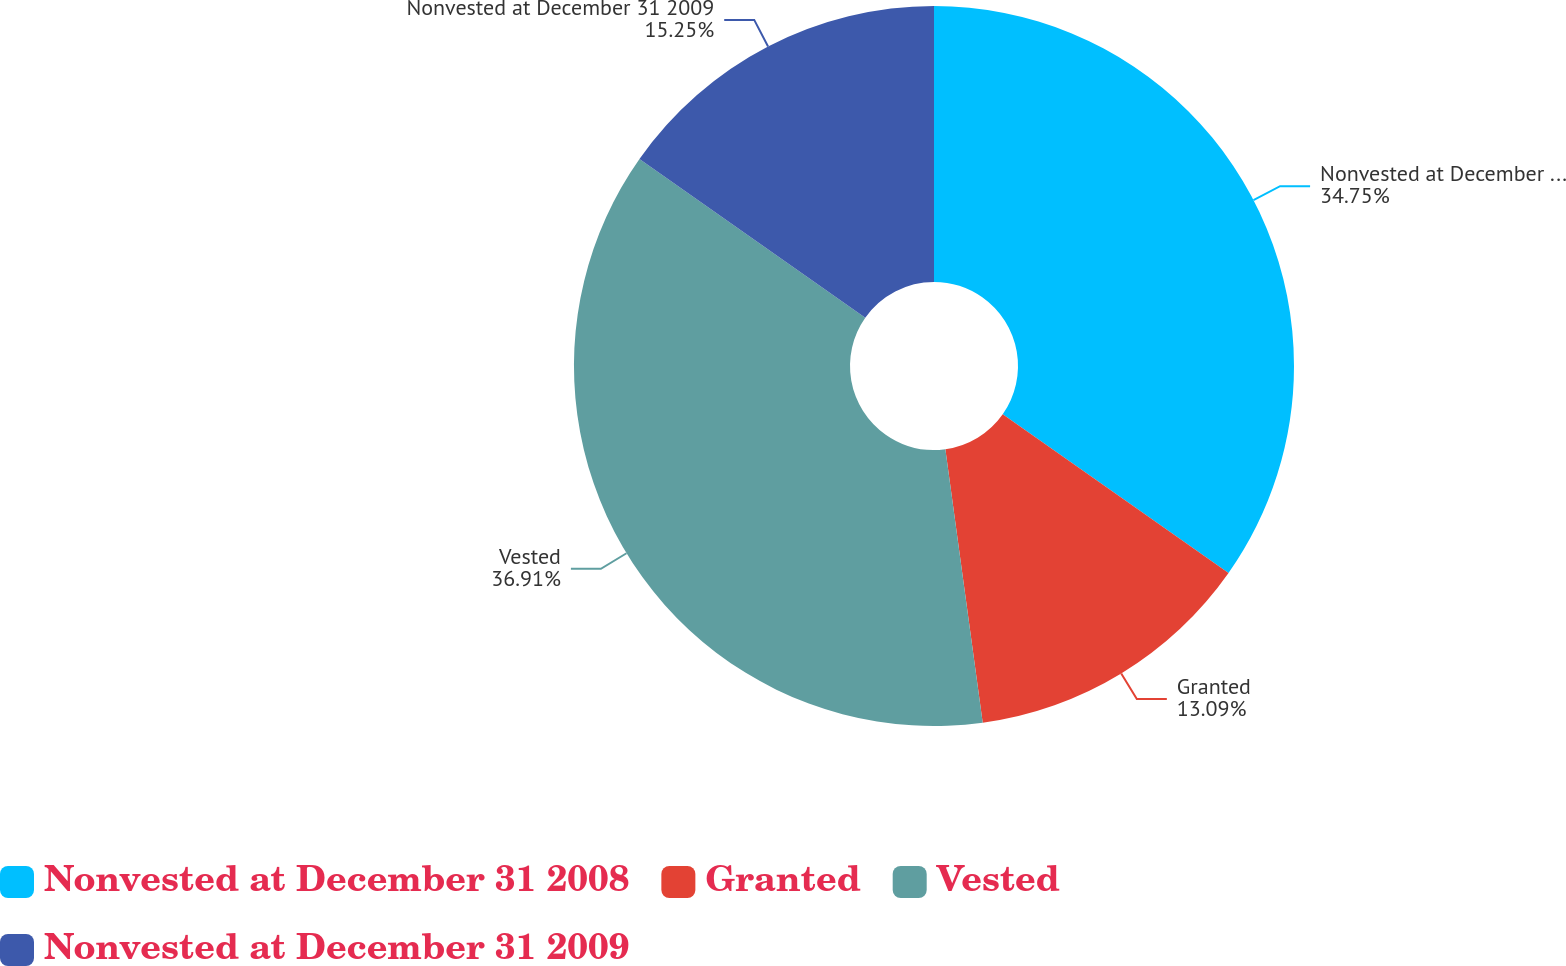Convert chart. <chart><loc_0><loc_0><loc_500><loc_500><pie_chart><fcel>Nonvested at December 31 2008<fcel>Granted<fcel>Vested<fcel>Nonvested at December 31 2009<nl><fcel>34.75%<fcel>13.09%<fcel>36.91%<fcel>15.25%<nl></chart> 